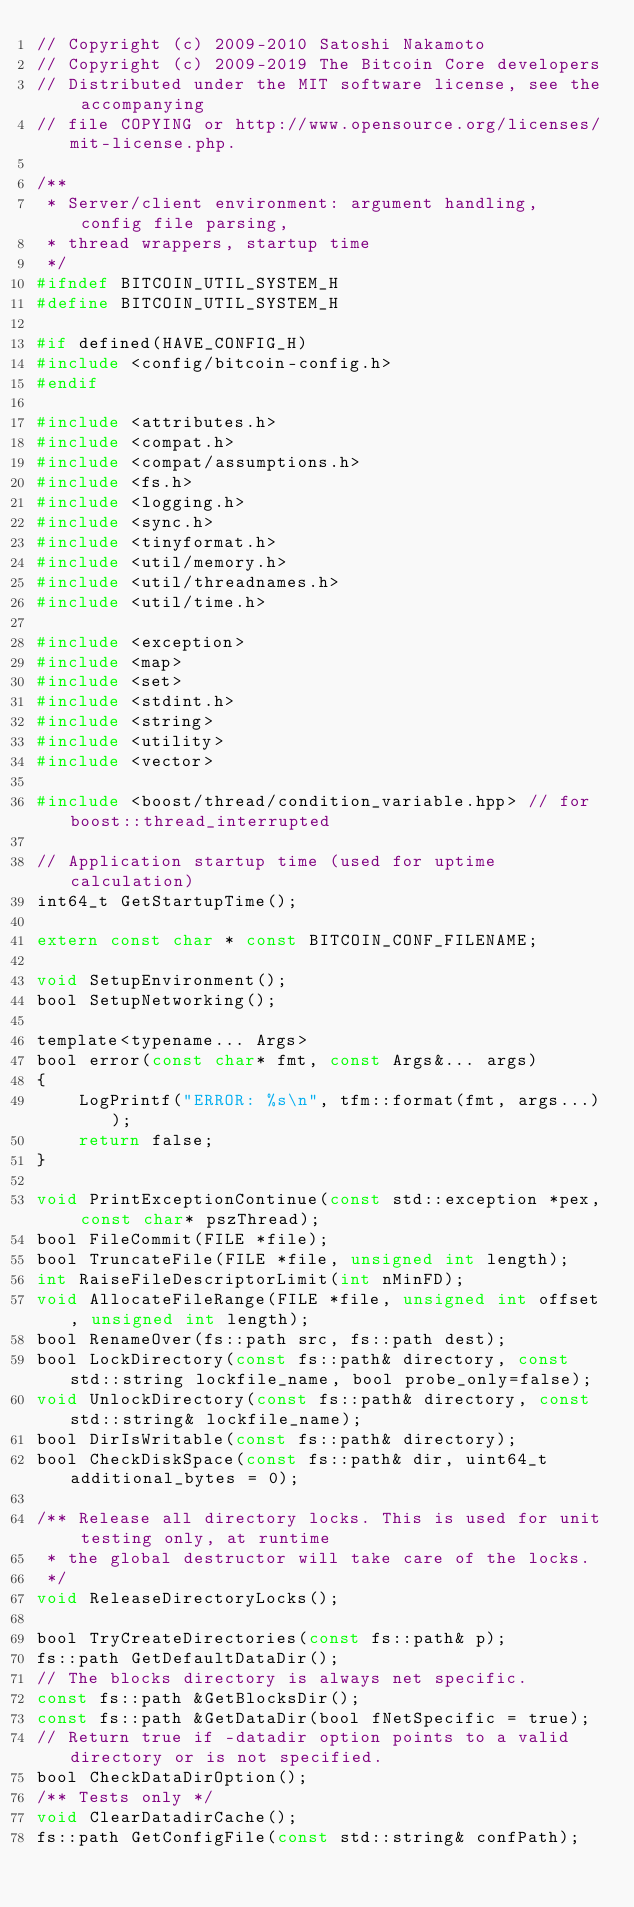<code> <loc_0><loc_0><loc_500><loc_500><_C_>// Copyright (c) 2009-2010 Satoshi Nakamoto
// Copyright (c) 2009-2019 The Bitcoin Core developers
// Distributed under the MIT software license, see the accompanying
// file COPYING or http://www.opensource.org/licenses/mit-license.php.

/**
 * Server/client environment: argument handling, config file parsing,
 * thread wrappers, startup time
 */
#ifndef BITCOIN_UTIL_SYSTEM_H
#define BITCOIN_UTIL_SYSTEM_H

#if defined(HAVE_CONFIG_H)
#include <config/bitcoin-config.h>
#endif

#include <attributes.h>
#include <compat.h>
#include <compat/assumptions.h>
#include <fs.h>
#include <logging.h>
#include <sync.h>
#include <tinyformat.h>
#include <util/memory.h>
#include <util/threadnames.h>
#include <util/time.h>

#include <exception>
#include <map>
#include <set>
#include <stdint.h>
#include <string>
#include <utility>
#include <vector>

#include <boost/thread/condition_variable.hpp> // for boost::thread_interrupted

// Application startup time (used for uptime calculation)
int64_t GetStartupTime();

extern const char * const BITCOIN_CONF_FILENAME;

void SetupEnvironment();
bool SetupNetworking();

template<typename... Args>
bool error(const char* fmt, const Args&... args)
{
    LogPrintf("ERROR: %s\n", tfm::format(fmt, args...));
    return false;
}

void PrintExceptionContinue(const std::exception *pex, const char* pszThread);
bool FileCommit(FILE *file);
bool TruncateFile(FILE *file, unsigned int length);
int RaiseFileDescriptorLimit(int nMinFD);
void AllocateFileRange(FILE *file, unsigned int offset, unsigned int length);
bool RenameOver(fs::path src, fs::path dest);
bool LockDirectory(const fs::path& directory, const std::string lockfile_name, bool probe_only=false);
void UnlockDirectory(const fs::path& directory, const std::string& lockfile_name);
bool DirIsWritable(const fs::path& directory);
bool CheckDiskSpace(const fs::path& dir, uint64_t additional_bytes = 0);

/** Release all directory locks. This is used for unit testing only, at runtime
 * the global destructor will take care of the locks.
 */
void ReleaseDirectoryLocks();

bool TryCreateDirectories(const fs::path& p);
fs::path GetDefaultDataDir();
// The blocks directory is always net specific.
const fs::path &GetBlocksDir();
const fs::path &GetDataDir(bool fNetSpecific = true);
// Return true if -datadir option points to a valid directory or is not specified.
bool CheckDataDirOption();
/** Tests only */
void ClearDatadirCache();
fs::path GetConfigFile(const std::string& confPath);</code> 